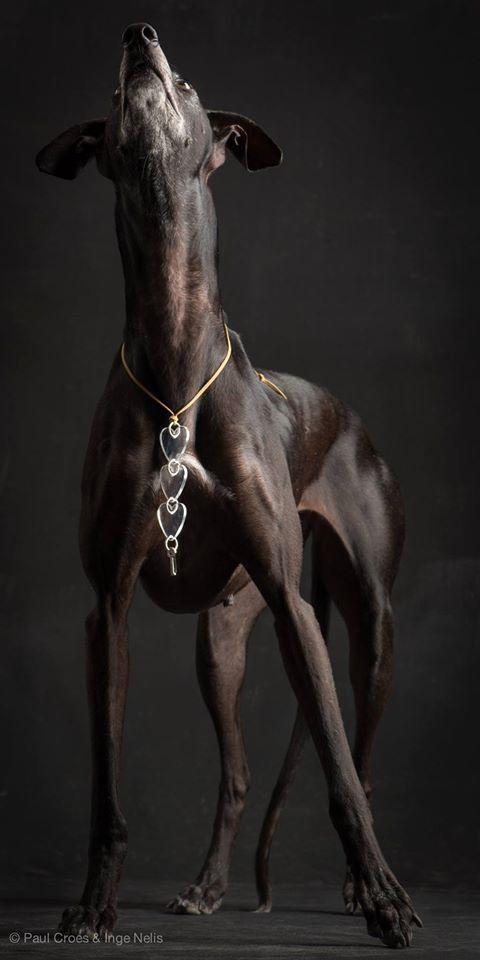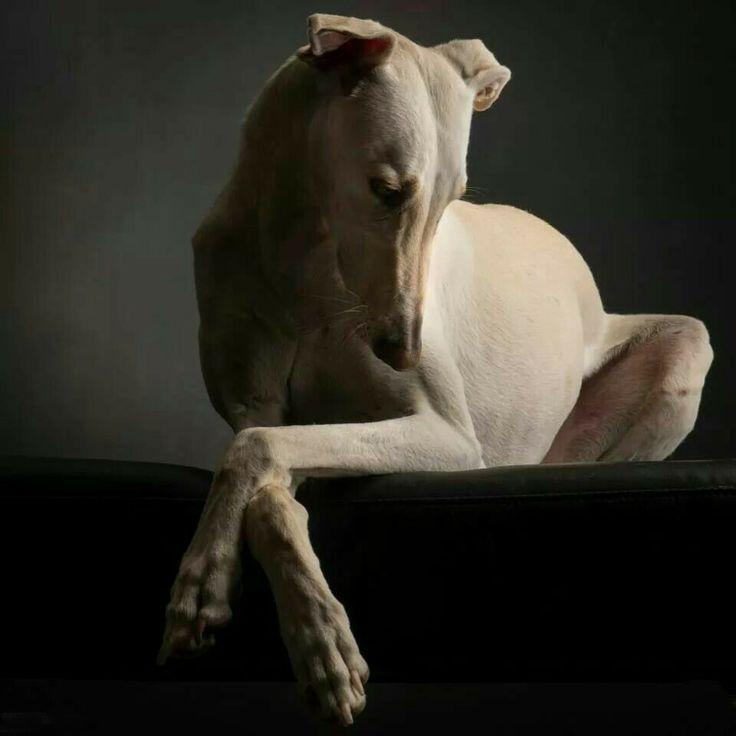The first image is the image on the left, the second image is the image on the right. Assess this claim about the two images: "All the dogs in the images are posing for portraits wearing collars.". Correct or not? Answer yes or no. No. 